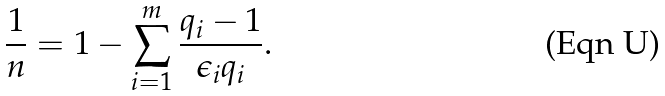Convert formula to latex. <formula><loc_0><loc_0><loc_500><loc_500>\frac { 1 } { n } = 1 - \sum _ { i = 1 } ^ { m } \frac { q _ { i } - 1 } { \epsilon _ { i } q _ { i } } .</formula> 